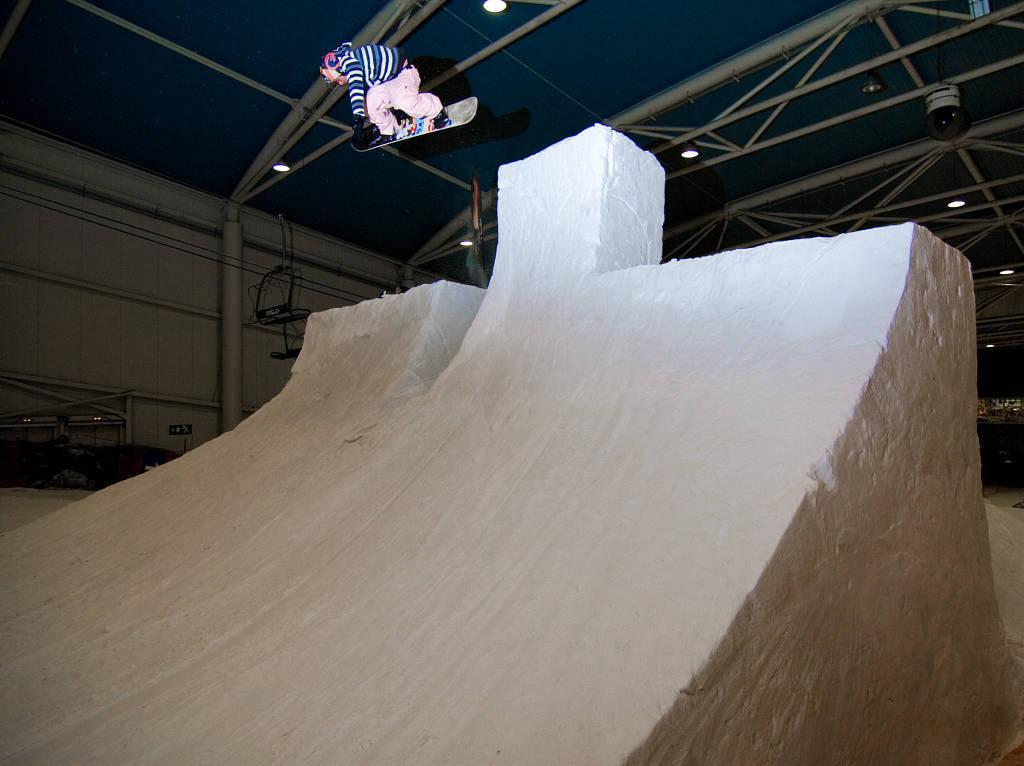What is the main activity taking place in the image? There is a ski drop-in in the image, and a man is on a skiing board in the air. What can be seen on the left side of the image? There is a wall on the left side of the image. How many trees are visible in the image? There are no trees visible in the image; it features a ski drop-in and a man on a skiing board. What type of fruit is the man holding while skiing in the image? There is no fruit present in the image, and the man is not holding anything while skiing. 